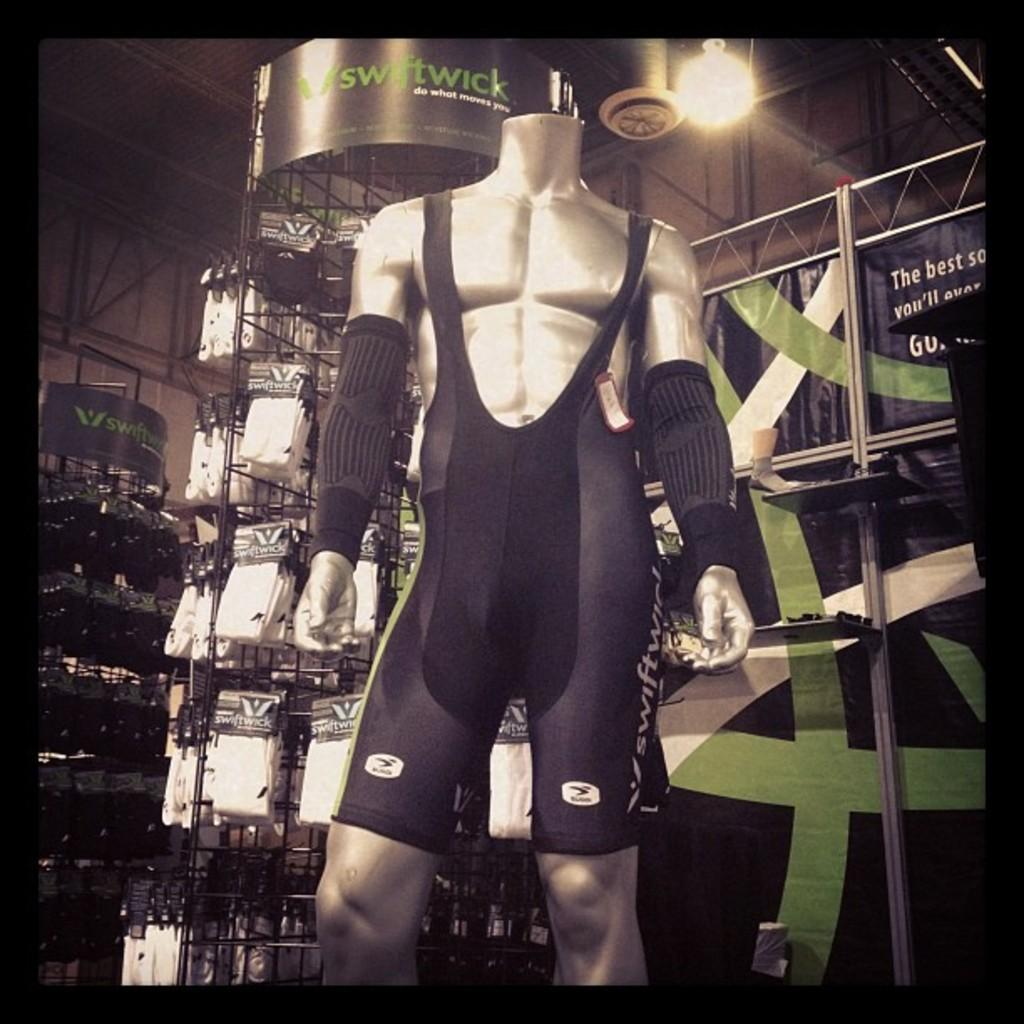What is the main subject in the image? There is a mannequin in the image. What can be seen attached to the mannequin? There is a tag on the mannequin. What is visible behind the mannequin? There are posters visible at the back of the mannequin. What type of furniture or structure is present in the image? There are racks in the image. What is the source of light in the image? There is a light in the image. What type of vertical structures can be seen in the image? There are rods in the image. What else can be seen in the image besides the mannequin and its accessories? There are some objects visible in the image. What type of hairstyle does the mannequin have in the image? The mannequin does not have a hairstyle, as it is an inanimate object. 